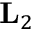Convert formula to latex. <formula><loc_0><loc_0><loc_500><loc_500>L _ { 2 }</formula> 